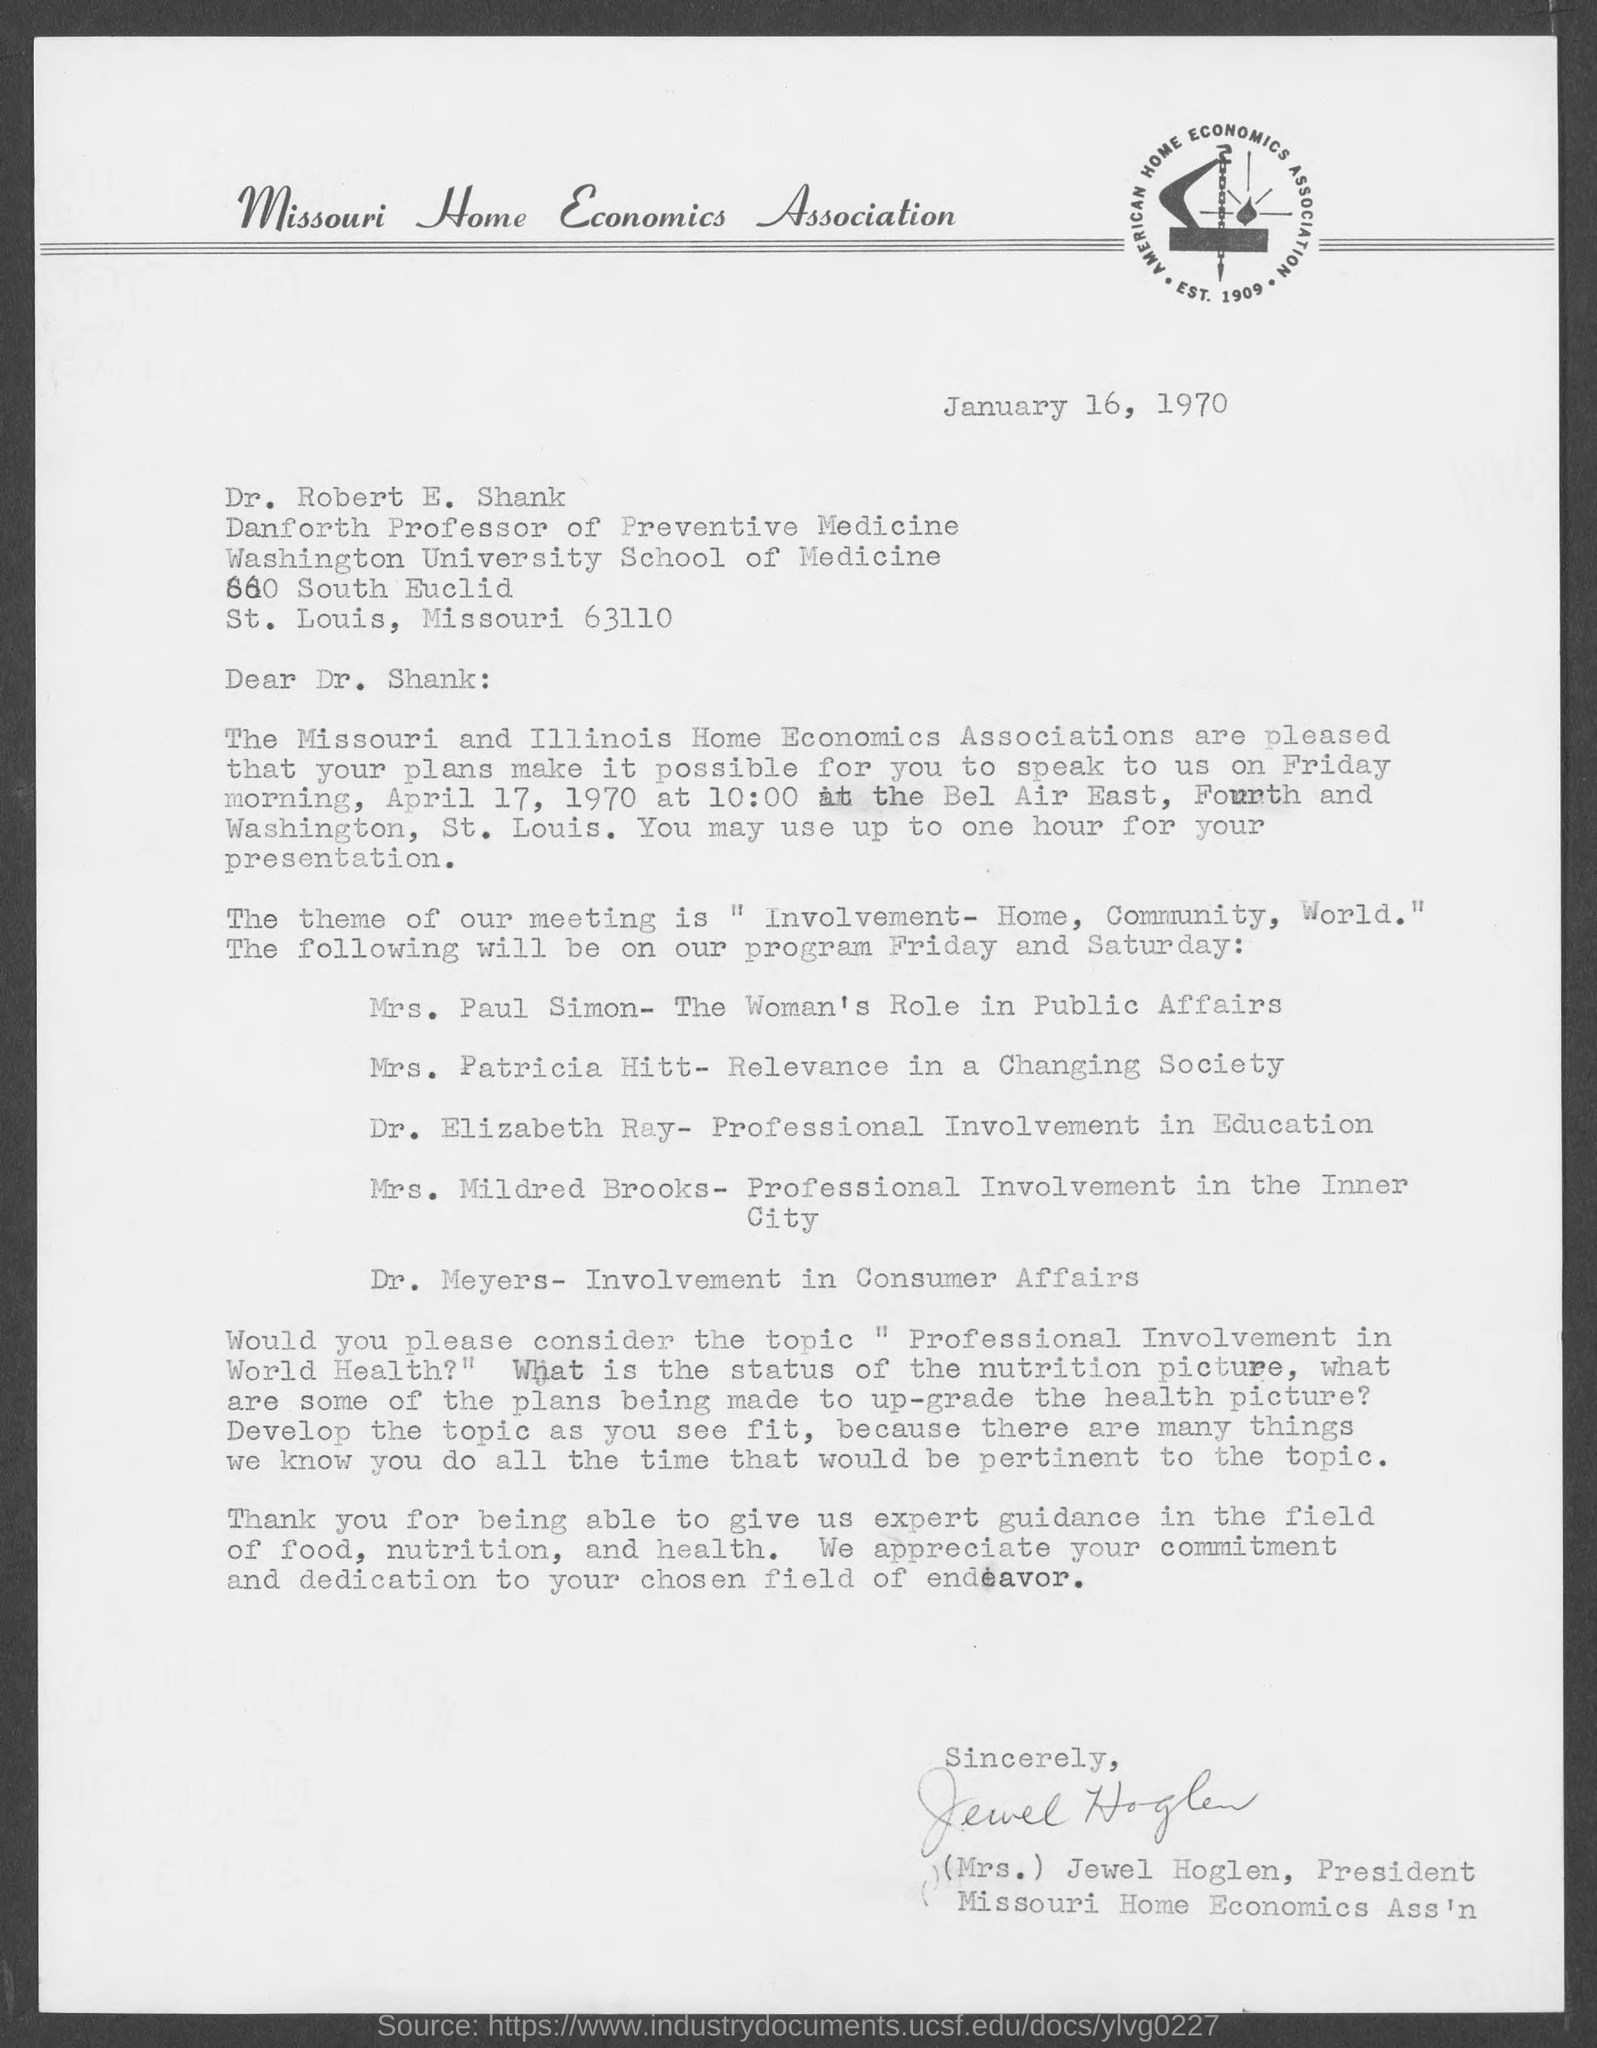Who wrote this letter?
Ensure brevity in your answer.  (MRS.) JEWEL HOGLEN. What is the position of (mrs.) jewel hoglen ?
Offer a very short reply. President, Missouri Home Economics Ass'n. To whom is this letter written to?
Offer a terse response. Dr. Robert E. Shank. What is the position of dr. robert e. shank ?
Your answer should be very brief. DANFORTH PROFESSOR OF PREVENTIVE MEDICINE. 